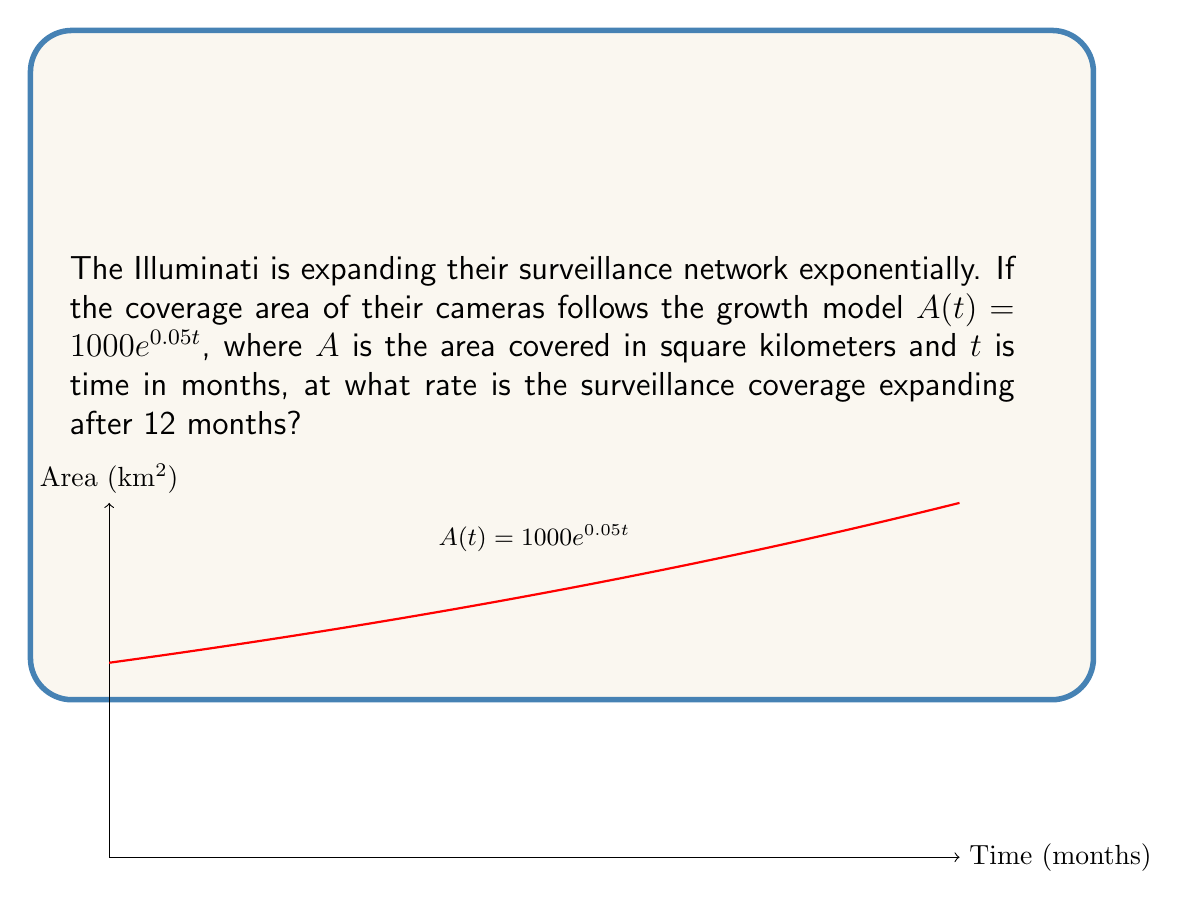Solve this math problem. To find the rate of change in surveillance coverage, we need to differentiate the given growth model with respect to time:

1) Given: $A(t) = 1000e^{0.05t}$

2) Differentiate $A(t)$ with respect to $t$:
   $$\frac{dA}{dt} = 1000 \cdot 0.05e^{0.05t} = 50e^{0.05t}$$

3) This derivative represents the rate of change of the area at any time $t$.

4) To find the rate after 12 months, substitute $t = 12$ into the derivative:
   $$\frac{dA}{dt}\bigg|_{t=12} = 50e^{0.05(12)} = 50e^{0.6}$$

5) Calculate the value:
   $$50e^{0.6} \approx 91.32$$

Therefore, after 12 months, the surveillance coverage is expanding at a rate of approximately 91.32 square kilometers per month.
Answer: $91.32 \text{ km}^2/\text{month}$ 